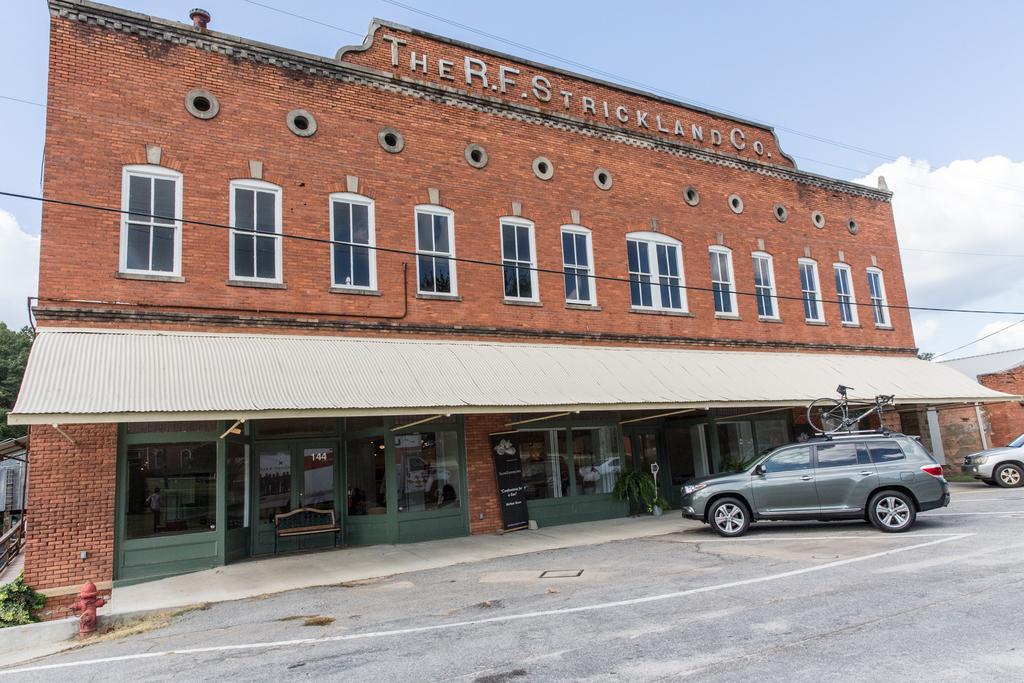Could you give a brief overview of what you see in this image? In this picture we can see vehicles on the road, hydrant, bench, fence, plants, building with windows, doors, sunshade, some objects and in the background we can see trees and the sky. 